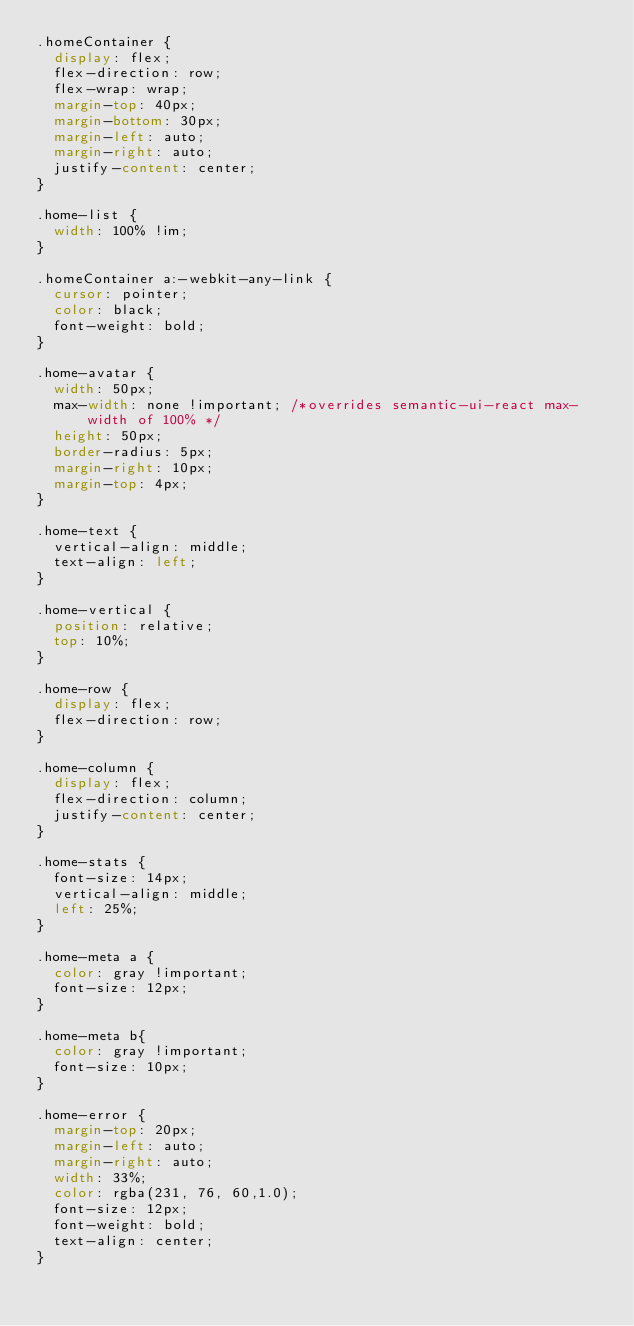<code> <loc_0><loc_0><loc_500><loc_500><_CSS_>.homeContainer {
  display: flex;
  flex-direction: row;
  flex-wrap: wrap;
  margin-top: 40px;
  margin-bottom: 30px;
  margin-left: auto;
  margin-right: auto;
  justify-content: center;
}

.home-list {
  width: 100% !im;
}

.homeContainer a:-webkit-any-link {
  cursor: pointer;
  color: black;
  font-weight: bold;
}

.home-avatar {
  width: 50px;
  max-width: none !important; /*overrides semantic-ui-react max-width of 100% */
  height: 50px;
  border-radius: 5px;
  margin-right: 10px;
  margin-top: 4px;
}

.home-text {
  vertical-align: middle;
  text-align: left;
}

.home-vertical {
  position: relative;
  top: 10%;
}

.home-row {
  display: flex;
  flex-direction: row;
}

.home-column {
  display: flex;
  flex-direction: column;
  justify-content: center;
}

.home-stats {
  font-size: 14px;
  vertical-align: middle;
  left: 25%;
}

.home-meta a {
  color: gray !important;
  font-size: 12px;
}

.home-meta b{
  color: gray !important;
  font-size: 10px;
}

.home-error {
  margin-top: 20px;
  margin-left: auto;
  margin-right: auto;
  width: 33%;
  color: rgba(231, 76, 60,1.0);
  font-size: 12px;
  font-weight: bold;
  text-align: center;
}
</code> 